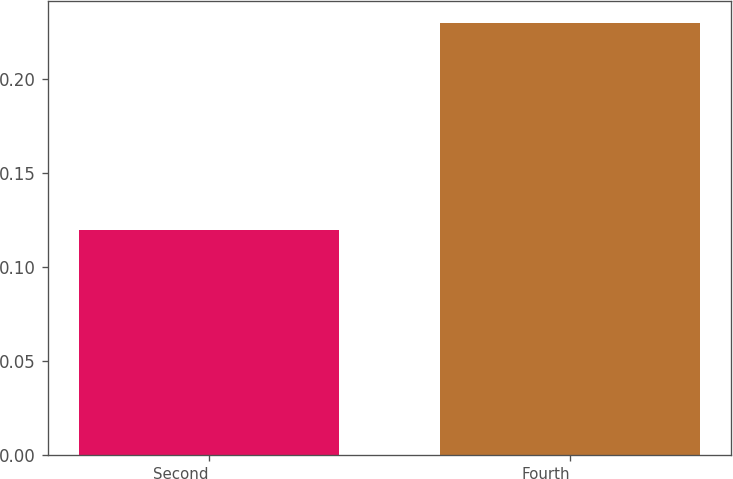Convert chart to OTSL. <chart><loc_0><loc_0><loc_500><loc_500><bar_chart><fcel>Second<fcel>Fourth<nl><fcel>0.12<fcel>0.23<nl></chart> 